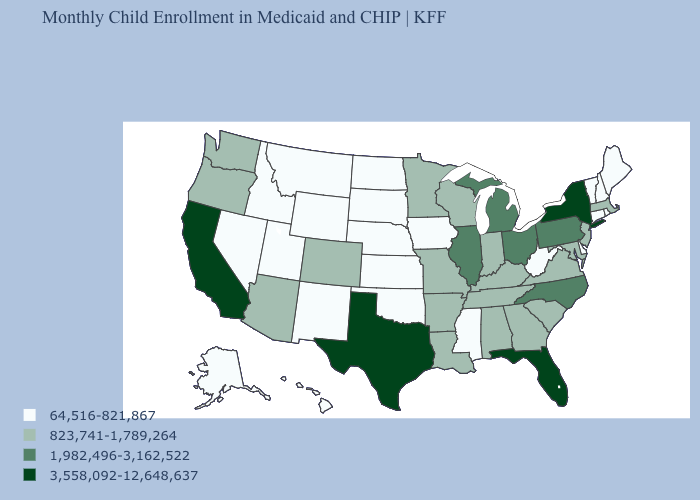Does the first symbol in the legend represent the smallest category?
Answer briefly. Yes. What is the value of Delaware?
Quick response, please. 64,516-821,867. Which states hav the highest value in the Northeast?
Short answer required. New York. Name the states that have a value in the range 823,741-1,789,264?
Keep it brief. Alabama, Arizona, Arkansas, Colorado, Georgia, Indiana, Kentucky, Louisiana, Maryland, Massachusetts, Minnesota, Missouri, New Jersey, Oregon, South Carolina, Tennessee, Virginia, Washington, Wisconsin. What is the value of Kentucky?
Answer briefly. 823,741-1,789,264. Among the states that border Iowa , does Nebraska have the lowest value?
Quick response, please. Yes. Which states have the lowest value in the MidWest?
Quick response, please. Iowa, Kansas, Nebraska, North Dakota, South Dakota. Does the map have missing data?
Answer briefly. No. What is the highest value in the West ?
Quick response, please. 3,558,092-12,648,637. Name the states that have a value in the range 3,558,092-12,648,637?
Concise answer only. California, Florida, New York, Texas. Does the first symbol in the legend represent the smallest category?
Keep it brief. Yes. Does the first symbol in the legend represent the smallest category?
Be succinct. Yes. Does Nevada have the same value as Oregon?
Concise answer only. No. Does Pennsylvania have the highest value in the Northeast?
Answer briefly. No. Name the states that have a value in the range 64,516-821,867?
Quick response, please. Alaska, Connecticut, Delaware, Hawaii, Idaho, Iowa, Kansas, Maine, Mississippi, Montana, Nebraska, Nevada, New Hampshire, New Mexico, North Dakota, Oklahoma, Rhode Island, South Dakota, Utah, Vermont, West Virginia, Wyoming. 